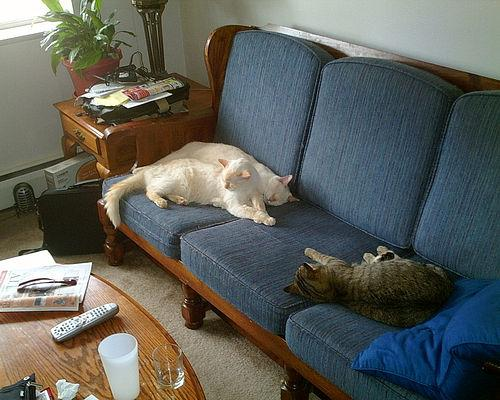What is the silver object on the table in front of the couch used to control? Please explain your reasoning. tv. The object is the tv. 